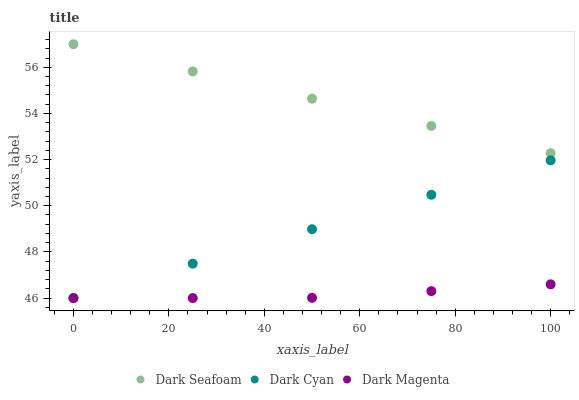Does Dark Magenta have the minimum area under the curve?
Answer yes or no. Yes. Does Dark Seafoam have the maximum area under the curve?
Answer yes or no. Yes. Does Dark Seafoam have the minimum area under the curve?
Answer yes or no. No. Does Dark Magenta have the maximum area under the curve?
Answer yes or no. No. Is Dark Cyan the smoothest?
Answer yes or no. Yes. Is Dark Magenta the roughest?
Answer yes or no. Yes. Is Dark Magenta the smoothest?
Answer yes or no. No. Is Dark Seafoam the roughest?
Answer yes or no. No. Does Dark Cyan have the lowest value?
Answer yes or no. Yes. Does Dark Seafoam have the lowest value?
Answer yes or no. No. Does Dark Seafoam have the highest value?
Answer yes or no. Yes. Does Dark Magenta have the highest value?
Answer yes or no. No. Is Dark Magenta less than Dark Seafoam?
Answer yes or no. Yes. Is Dark Seafoam greater than Dark Cyan?
Answer yes or no. Yes. Does Dark Magenta intersect Dark Cyan?
Answer yes or no. Yes. Is Dark Magenta less than Dark Cyan?
Answer yes or no. No. Is Dark Magenta greater than Dark Cyan?
Answer yes or no. No. Does Dark Magenta intersect Dark Seafoam?
Answer yes or no. No. 